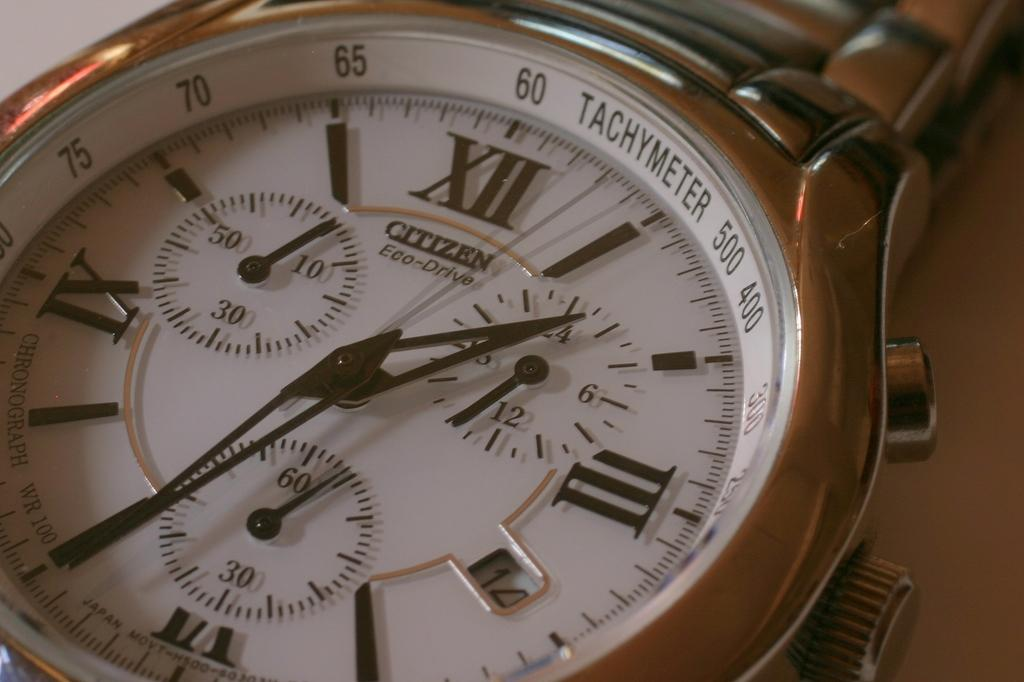<image>
Offer a succinct explanation of the picture presented. A close up of the face of a Citizen brand watch. 